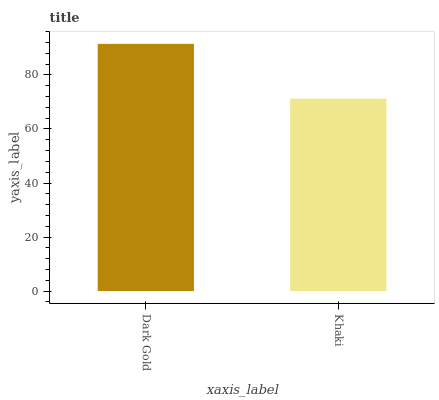Is Khaki the minimum?
Answer yes or no. Yes. Is Dark Gold the maximum?
Answer yes or no. Yes. Is Khaki the maximum?
Answer yes or no. No. Is Dark Gold greater than Khaki?
Answer yes or no. Yes. Is Khaki less than Dark Gold?
Answer yes or no. Yes. Is Khaki greater than Dark Gold?
Answer yes or no. No. Is Dark Gold less than Khaki?
Answer yes or no. No. Is Dark Gold the high median?
Answer yes or no. Yes. Is Khaki the low median?
Answer yes or no. Yes. Is Khaki the high median?
Answer yes or no. No. Is Dark Gold the low median?
Answer yes or no. No. 